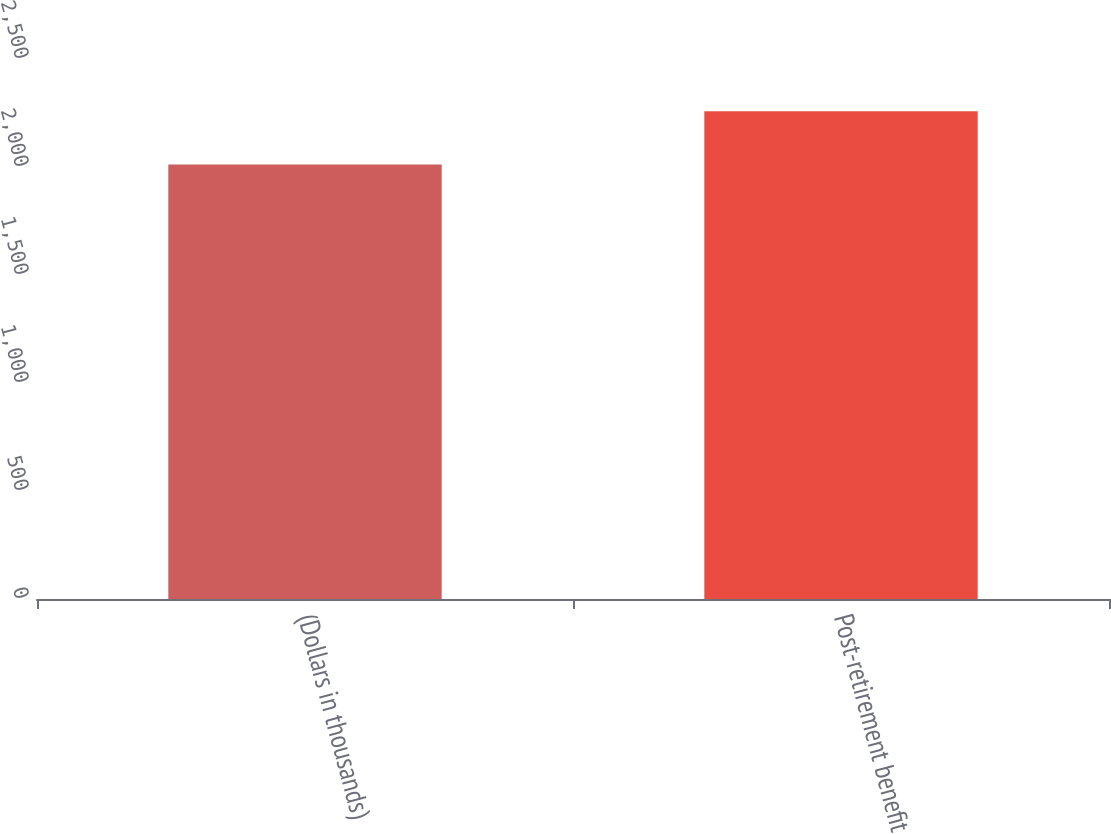Convert chart to OTSL. <chart><loc_0><loc_0><loc_500><loc_500><bar_chart><fcel>(Dollars in thousands)<fcel>Post-retirement benefit<nl><fcel>2011<fcel>2258<nl></chart> 